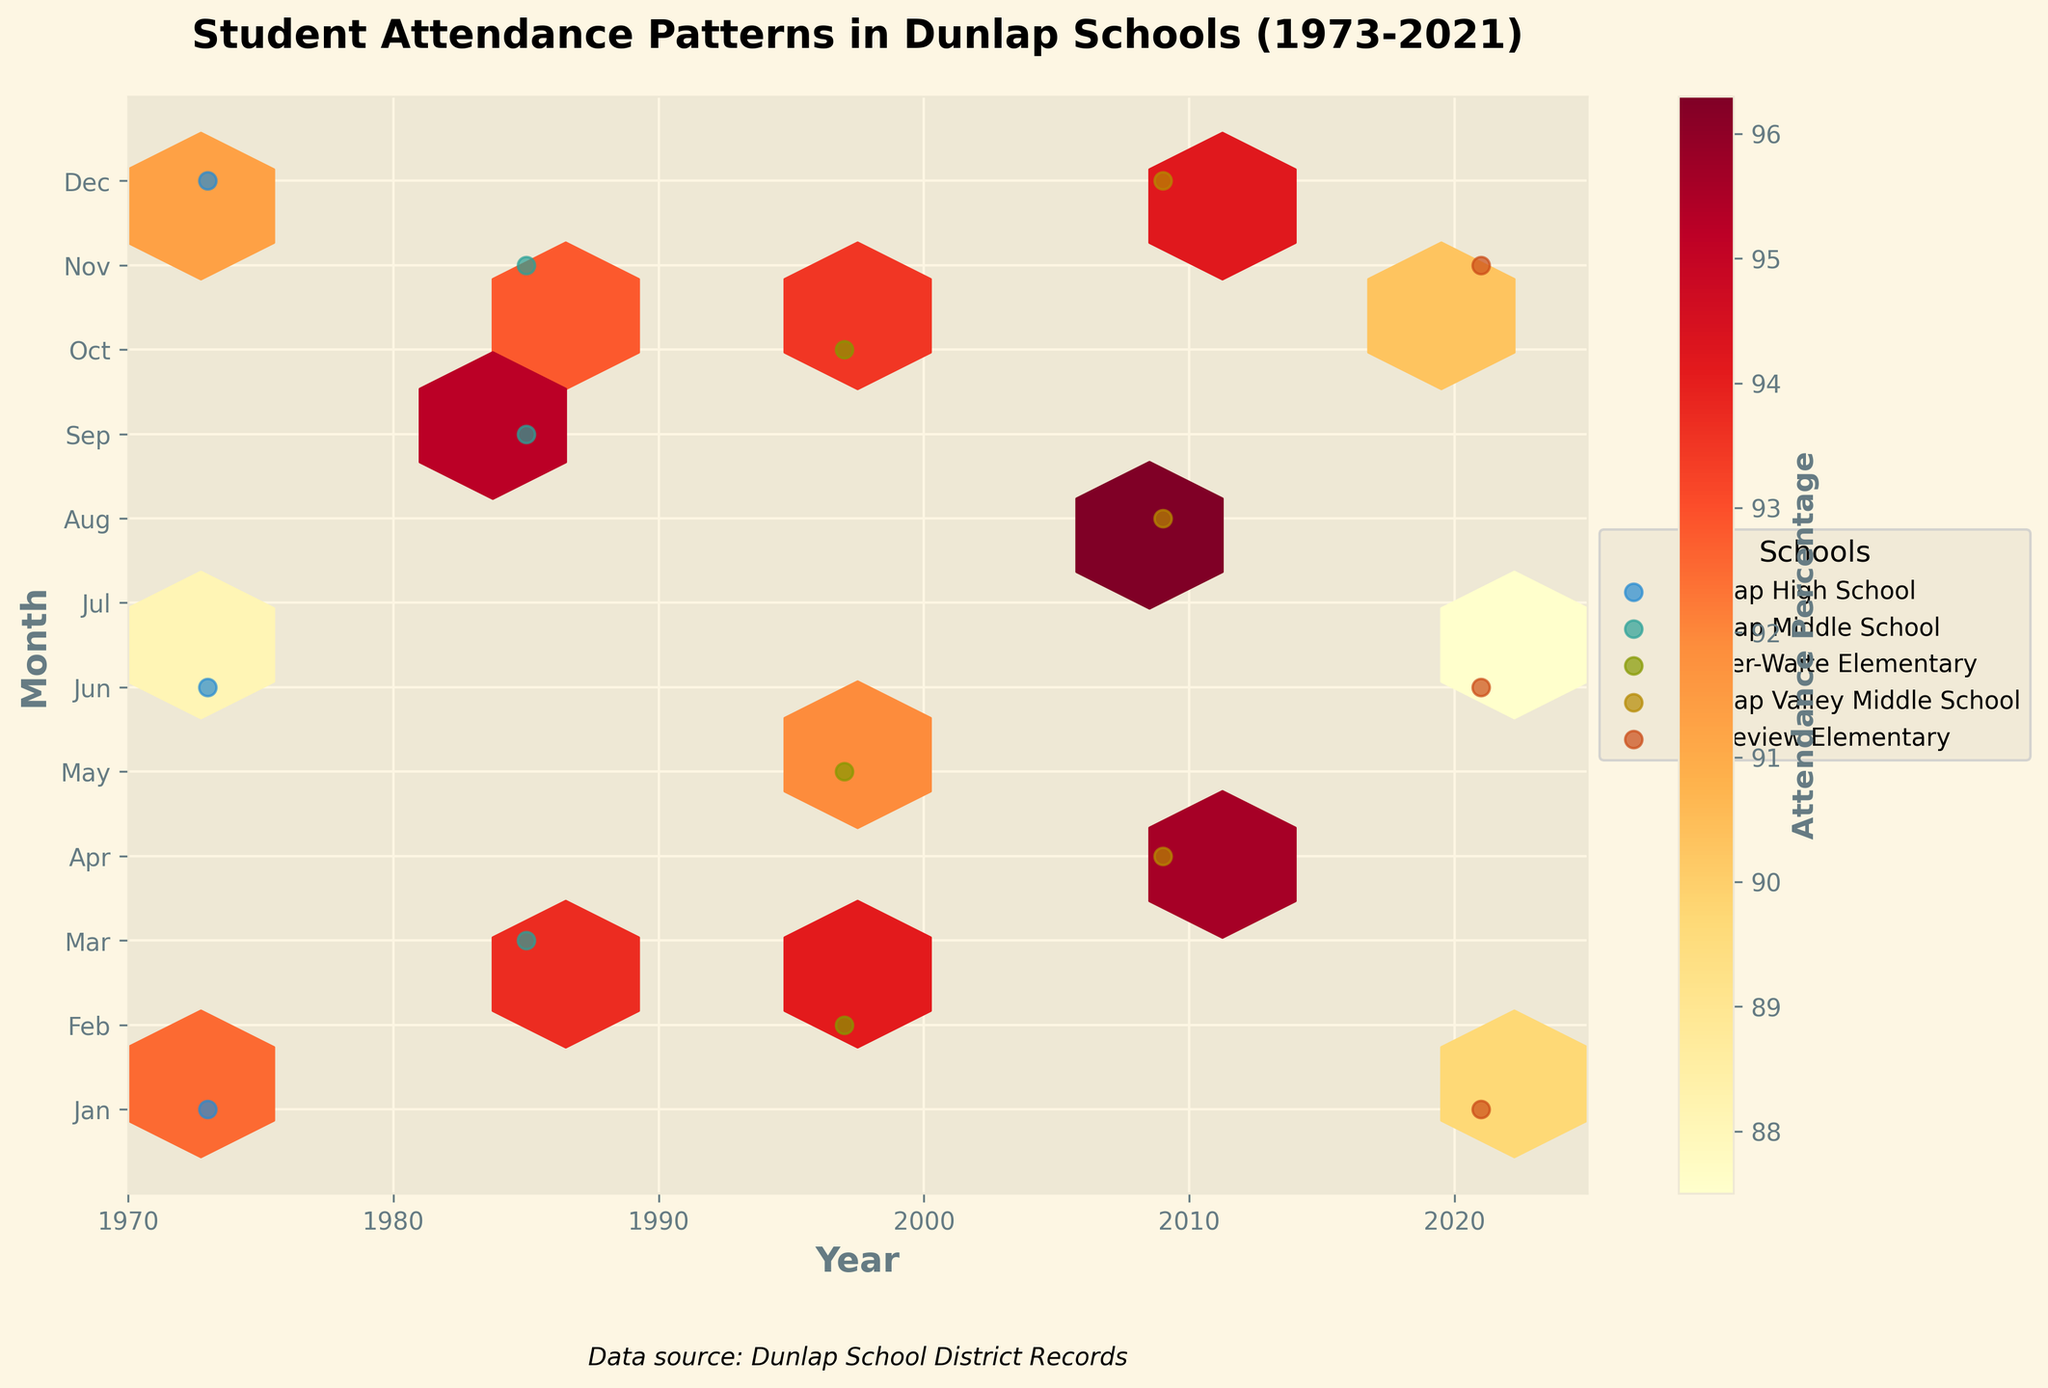What's the title of the figure? The title of the figure is written at the top and typically summarizes the information the plot represents.
Answer: Student Attendance Patterns in Dunlap Schools (1973-2021) What do the colors in the hexbin represent? The color bar next to the plot indicates that the colors represent the attendance percentage, with different shades showing variations.
Answer: Attendance Percentage Over the years, which month appears to have the highest attendance percentage on average? By observing the densest and most intensely colored hexagons, August often has higher attendance percentages.
Answer: August Which school shows data points across the most varied months? By examining the plotted points, Dunlap Valley Middle School has scatter points across various months.
Answer: Dunlap Valley Middle School In what period does Year 2021 show data, and how do the attendance percentages vary in these months? Year 2021 has data points in January, June, and November, with attendance percentages of 89.7, 87.5, and 90.3 respectively.
Answer: January, June, and November—89.7%, 87.5%, 90.3% How does the attendance percentage trend in 1973 compare across the recorded months? By looking at the three data points for 1973: January (92.5%), June (88.1%), and December (91.3%), there's a drop in June and then a rise in December.
Answer: Falls in June, rises in December Which school, based on the plot, had the highest attendance percentage in 2009? Looking at the plot and considering the plotted attendance percentage data in 2009, Dunlap Valley Middle School has high values.
Answer: Dunlap Valley Middle School What's the average attendance percentage for Ridgeview Elementary in the given data points? Add the percentages for Ridgeview Elementary (89.7, 87.5, 90.3) and divide by the number of data points (3): (89.7 + 87.5 + 90.3)/3 = 89.17%.
Answer: 89.17% What can be observed about the seasonal variation in attendance? Observing the y-axis (months) and the spread/gradient of the hexagons, attendance generally dips during summer months.
Answer: Dip in summer How does attendance percentage in Wilder-Waite Elementary in October 1997 compare to November 1985 in Dunlap Middle School? From the figure, October 1997 in Wilder-Waite Elementary shows 93.5%, while November 1985 in Dunlap Middle School is 92.8%.
Answer: 93.5% vs 92.8% 